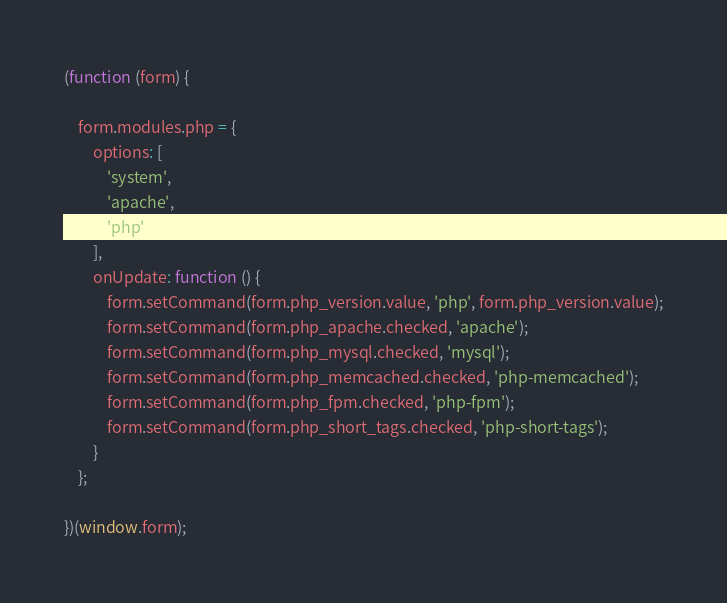<code> <loc_0><loc_0><loc_500><loc_500><_JavaScript_>(function (form) {

    form.modules.php = {
        options: [
            'system',
            'apache',
            'php'
        ],
        onUpdate: function () {
            form.setCommand(form.php_version.value, 'php', form.php_version.value);
            form.setCommand(form.php_apache.checked, 'apache');
            form.setCommand(form.php_mysql.checked, 'mysql');
            form.setCommand(form.php_memcached.checked, 'php-memcached');
            form.setCommand(form.php_fpm.checked, 'php-fpm');
            form.setCommand(form.php_short_tags.checked, 'php-short-tags');
        }
    };

})(window.form);
</code> 